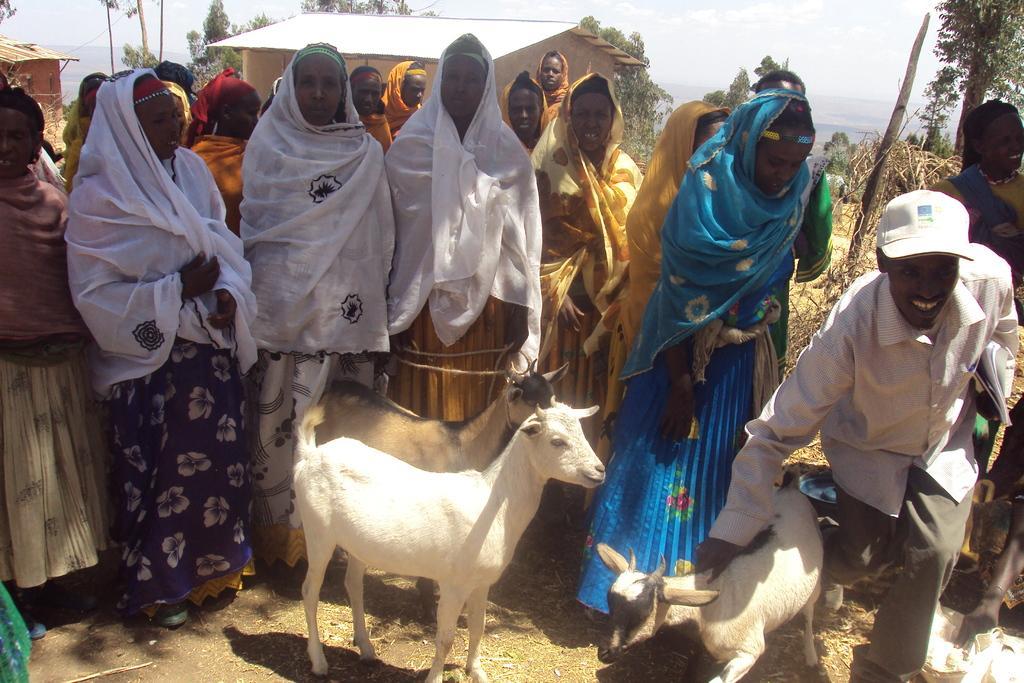In one or two sentences, can you explain what this image depicts? In this image I can see few people are standing. At the bottom there are few goats on the ground. On the right side a man is holding a goat in the hand and smiling. In the background, I can see few houses and trees. 